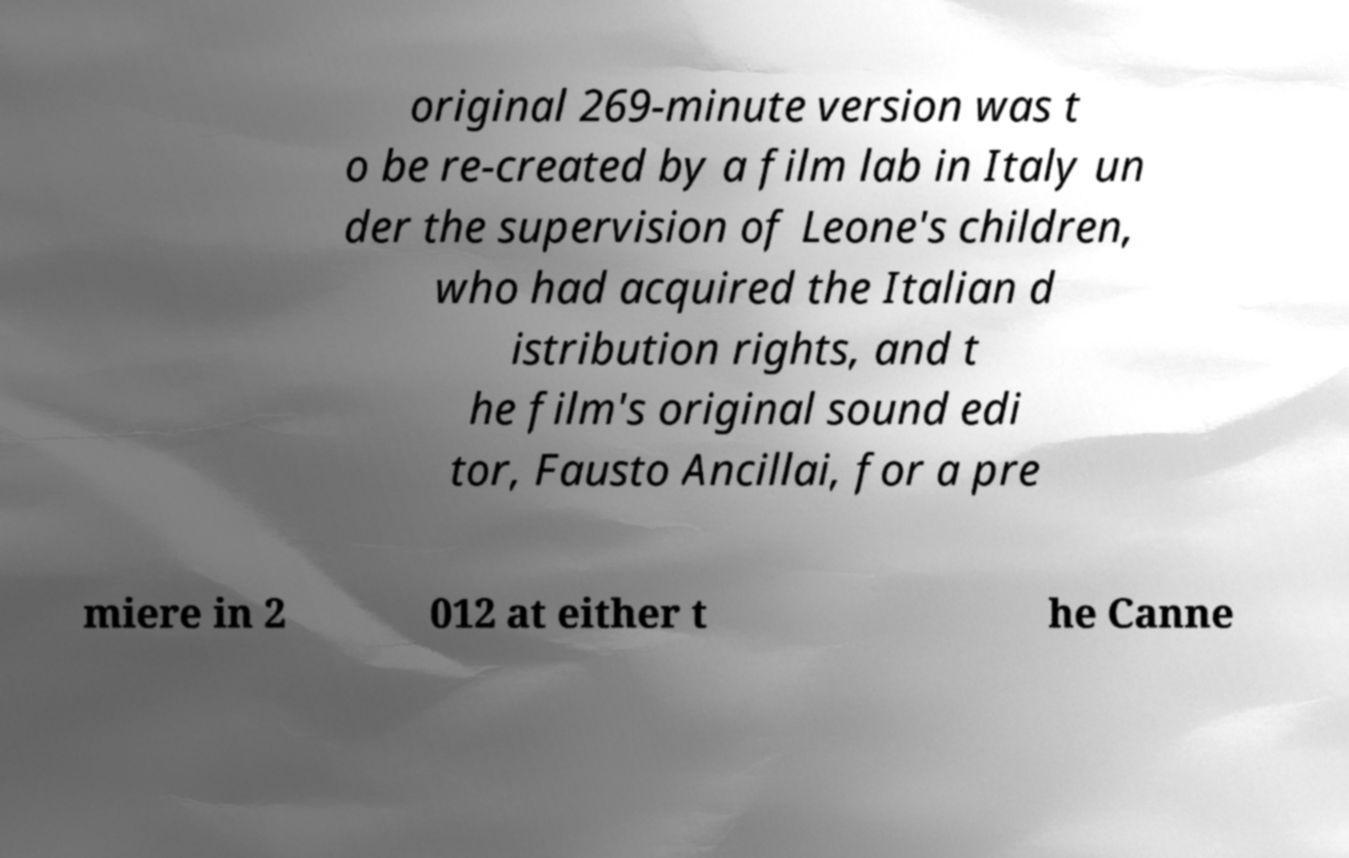Can you accurately transcribe the text from the provided image for me? original 269-minute version was t o be re-created by a film lab in Italy un der the supervision of Leone's children, who had acquired the Italian d istribution rights, and t he film's original sound edi tor, Fausto Ancillai, for a pre miere in 2 012 at either t he Canne 